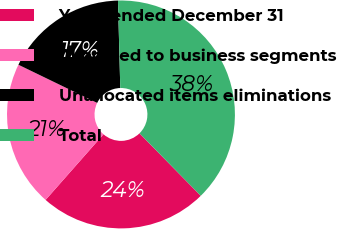Convert chart. <chart><loc_0><loc_0><loc_500><loc_500><pie_chart><fcel>Years ended December 31<fcel>Allocated to business segments<fcel>Unallocated items eliminations<fcel>Total<nl><fcel>23.85%<fcel>20.68%<fcel>17.4%<fcel>38.07%<nl></chart> 